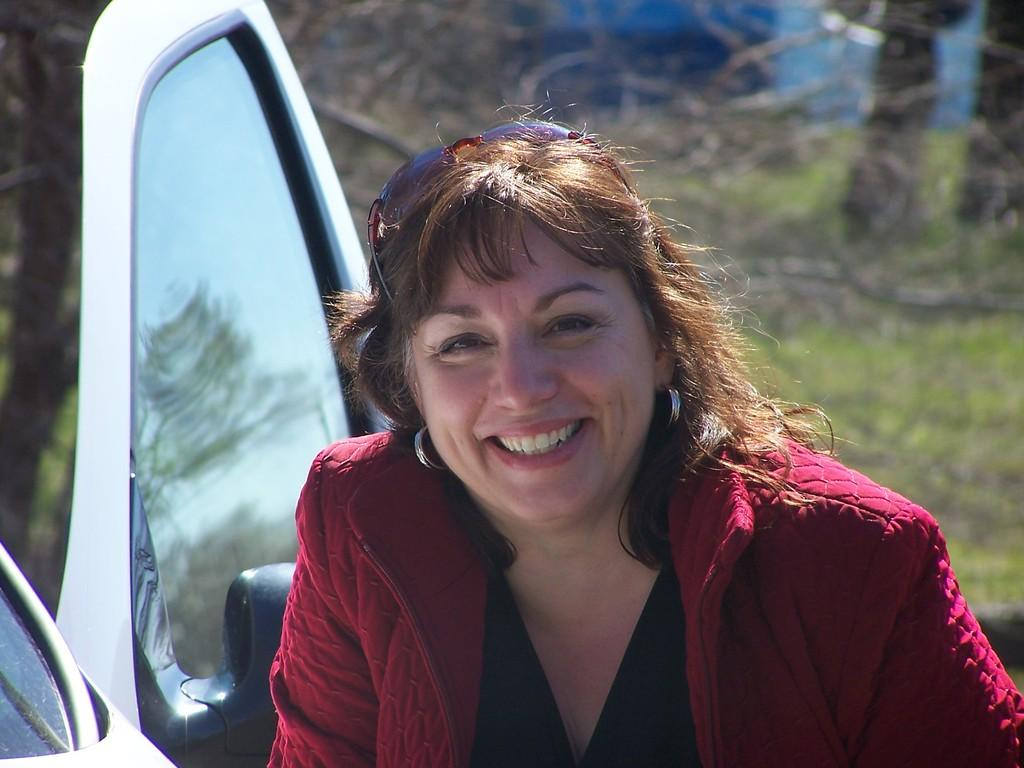Who or what is present in the image? There is a person in the image. What is the person wearing? The person is wearing a red and black color dress. What can be seen in the background of the image? There is a vehicle and trees with green color in the background of the image. What type of jewel is the person holding in their mouth in the image? There is no jewel or mouth visible in the image; the person is wearing a dress and standing in front of a vehicle and trees. 